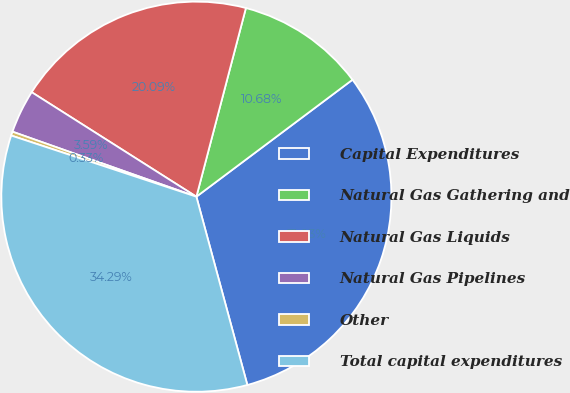<chart> <loc_0><loc_0><loc_500><loc_500><pie_chart><fcel>Capital Expenditures<fcel>Natural Gas Gathering and<fcel>Natural Gas Liquids<fcel>Natural Gas Pipelines<fcel>Other<fcel>Total capital expenditures<nl><fcel>31.03%<fcel>10.68%<fcel>20.09%<fcel>3.59%<fcel>0.33%<fcel>34.29%<nl></chart> 